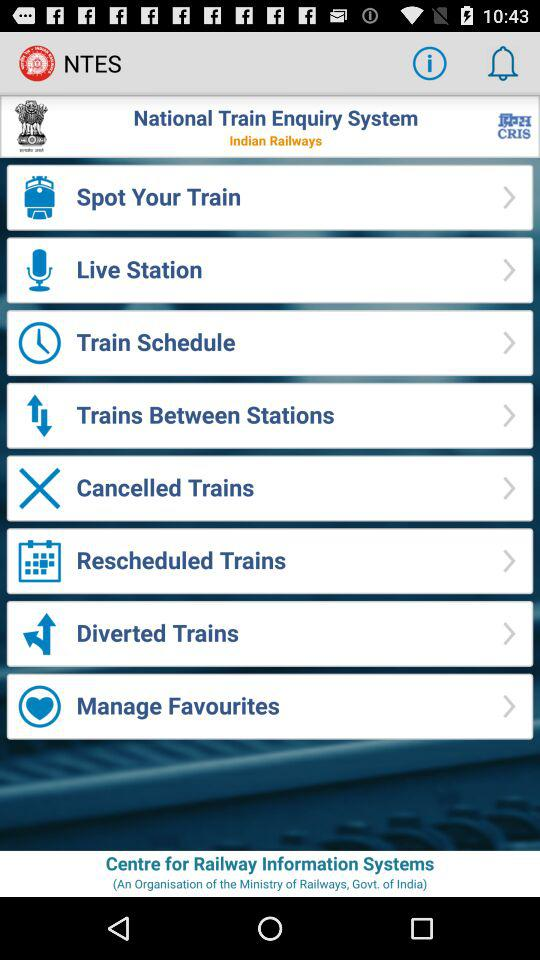What is the application name? The application name is "NTES". 